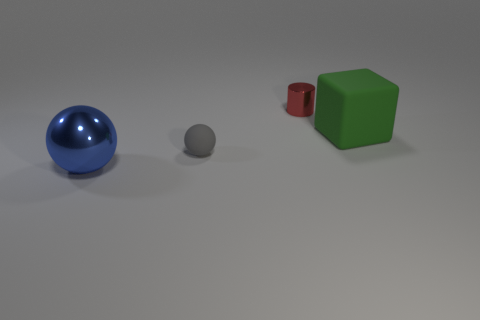Is there any other thing that has the same shape as the small red thing?
Give a very brief answer. No. Is there a big green cube made of the same material as the gray object?
Ensure brevity in your answer.  Yes. How many small rubber objects are there?
Offer a terse response. 1. There is a small object that is to the left of the tiny thing that is to the right of the tiny gray rubber sphere; what is its material?
Make the answer very short. Rubber. What is the color of the block that is made of the same material as the tiny sphere?
Offer a very short reply. Green. There is a metallic object that is to the left of the tiny metal cylinder; is it the same size as the rubber object that is in front of the big green block?
Ensure brevity in your answer.  No. How many spheres are either small gray shiny things or big blue things?
Your answer should be compact. 1. Is the tiny object that is in front of the small cylinder made of the same material as the big blue thing?
Give a very brief answer. No. How many other things are there of the same size as the cylinder?
Ensure brevity in your answer.  1. How many large things are green things or purple cubes?
Provide a short and direct response. 1. 